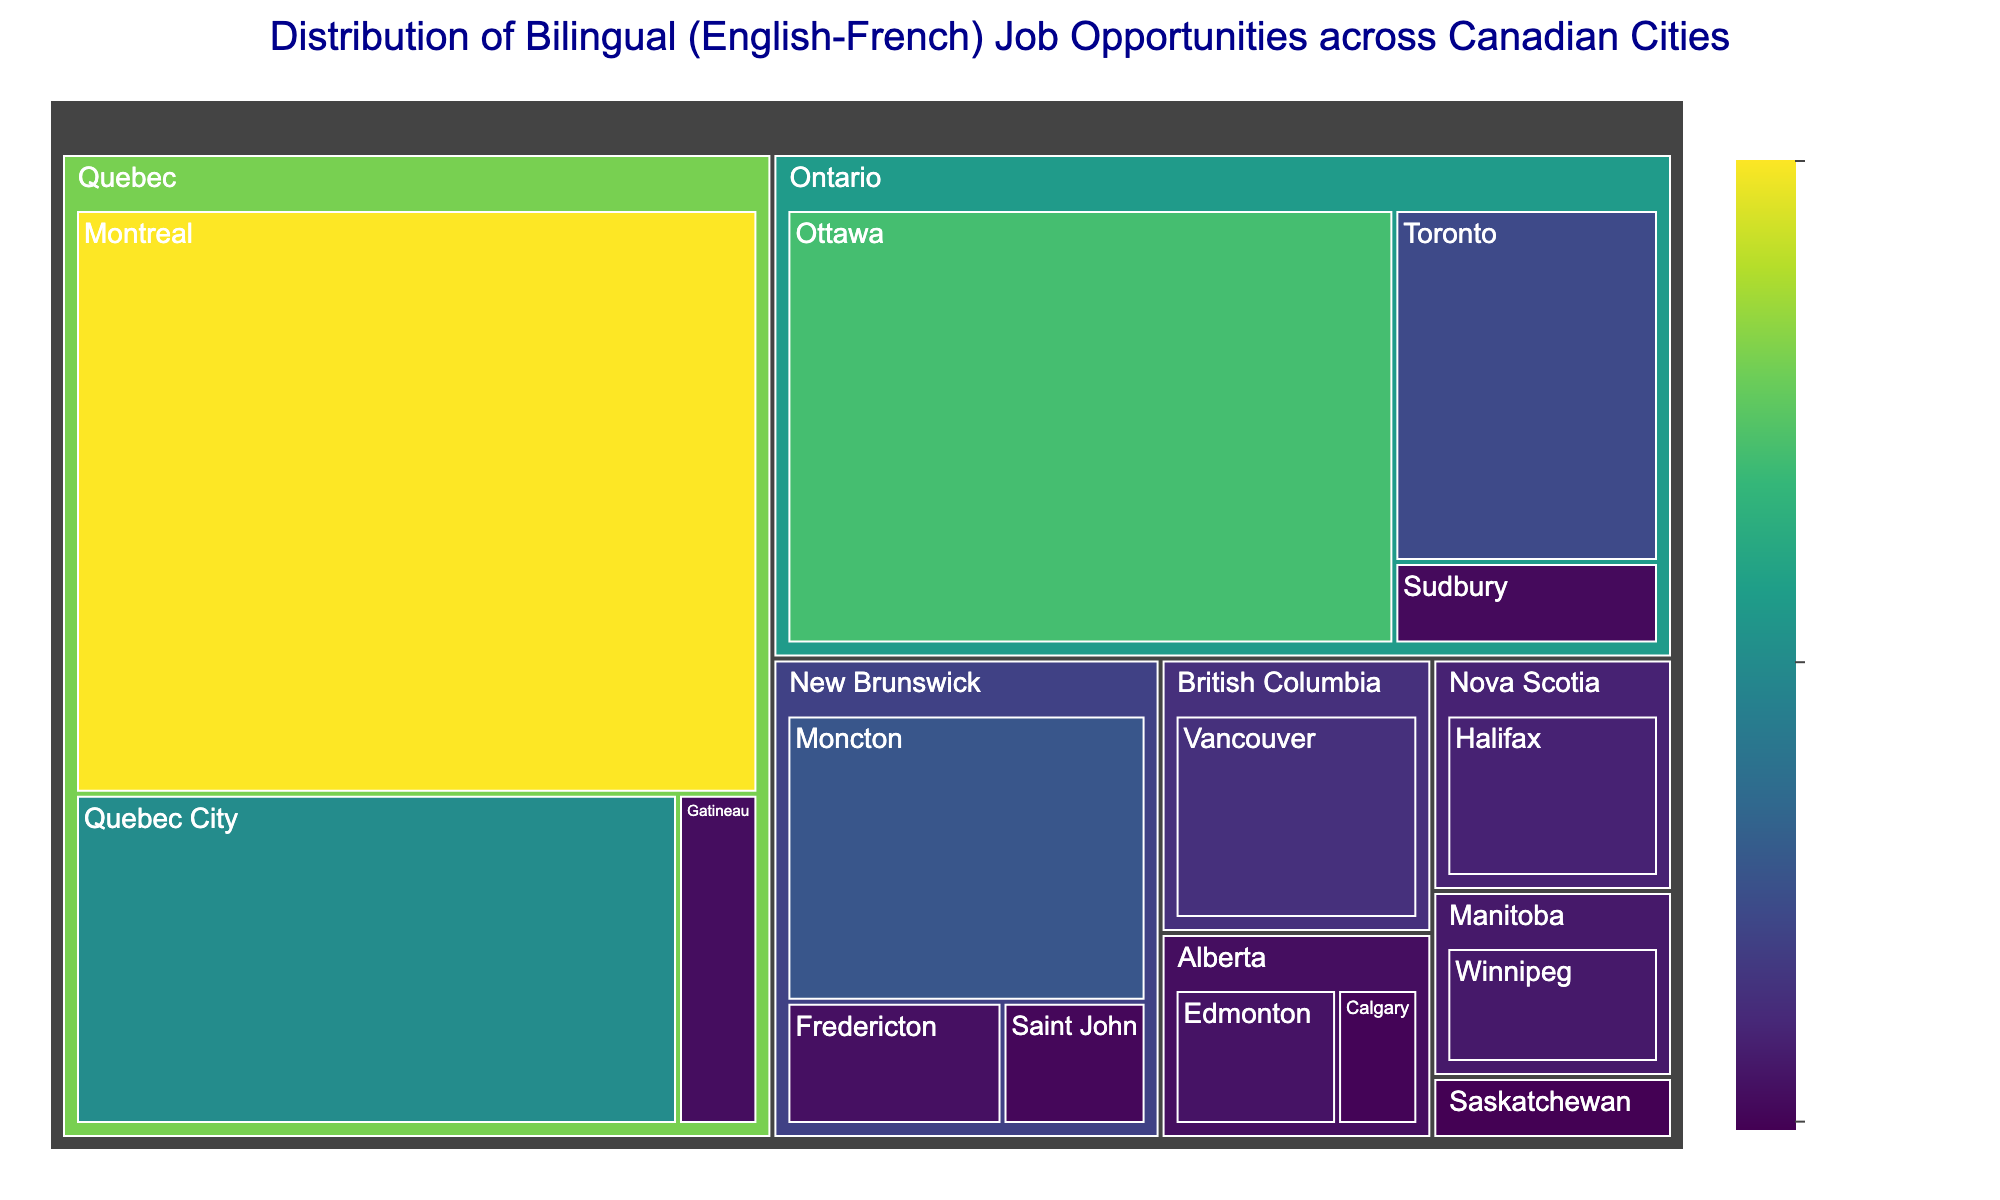What is the title of the treemap? The title is displayed at the top of the treemap, typically highlighting the figure's main topic. Look at the top center of the figure to find the title.
Answer: Distribution of Bilingual (English-French) Job Opportunities across Canadian Cities Which city has the highest number of bilingual job opportunities? The size of the tiles in a treemap usually represents the value. Look for the largest tile or the tile with the highest value in the figure.
Answer: Montreal How many bilingual job opportunities are there in Ontario? To find this, sum the number of job opportunities in all cities within Ontario (Ottawa: 850, Toronto: 300, Sudbury: 70).
Answer: 1220 Which province has the second highest number of bilingual job opportunities? First, identify the provinces and their total opportunities by summing for each. Compare Quebec (1200 + 600 + 80 = 1880) vs Ontario (850 + 300 + 70 = 1220) vs New Brunswick (350 + 90 + 60 = 500).
Answer: Ontario What is the average number of bilingual job opportunities in Alberta? Add the job opportunities of both cities in Alberta (Edmonton: 100, Calgary: 50) and divide by the number of cities. Average = (100 + 50) / 2 = 75.
Answer: 75 Is there a city in Quebec with fewer than 100 bilingual job opportunities? Look at the tiles within Quebec and check for any city with a value less than 100.
Answer: Yes, Gatineau Which city has a fewer bilingual job opportunities: Vancouver or Winnipeg? Compare the values associated with Vancouver and Winnipeg within their respective tiles.
Answer: Winnipeg Find the province with the lowest total number of bilingual job opportunities. Calculate the sum of bilingual job opportunities for each province and identify the smallest total. Saskatchewan: (Regina: 40).
Answer: Saskatchewan What is the color range used in the treemap to represent bilingual job opportunities? The color range in the treemap is defined by the color scale mentioned at the bottom right.
Answer: Viridis Comparing Moncton and Halifax, which city has more bilingual job opportunities and by how much? Identify the values for Moncton (350) and Halifax (150) within their tiles and calculate the difference (350 - 150).
Answer: Moncton, 200 